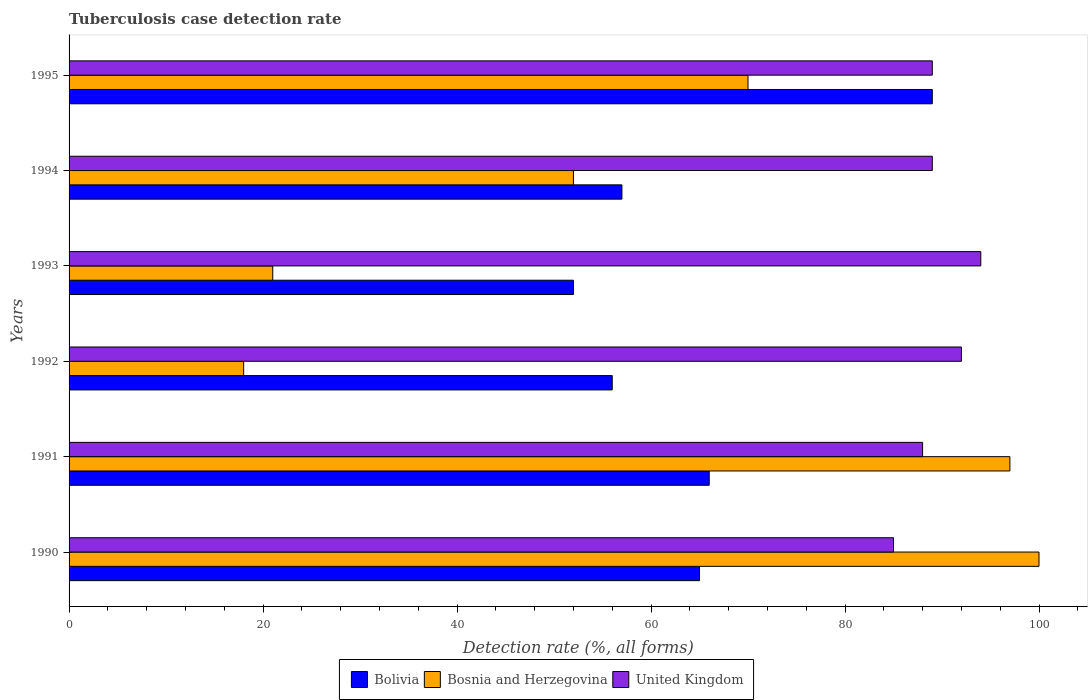What is the tuberculosis case detection rate in in Bolivia in 1993?
Your answer should be very brief. 52. Across all years, what is the maximum tuberculosis case detection rate in in Bolivia?
Provide a short and direct response. 89. Across all years, what is the minimum tuberculosis case detection rate in in Bolivia?
Offer a very short reply. 52. What is the total tuberculosis case detection rate in in Bosnia and Herzegovina in the graph?
Your response must be concise. 358. What is the difference between the tuberculosis case detection rate in in United Kingdom in 1992 and that in 1995?
Give a very brief answer. 3. What is the difference between the tuberculosis case detection rate in in Bosnia and Herzegovina in 1993 and the tuberculosis case detection rate in in United Kingdom in 1992?
Provide a short and direct response. -71. What is the average tuberculosis case detection rate in in Bolivia per year?
Make the answer very short. 64.17. In the year 1994, what is the difference between the tuberculosis case detection rate in in United Kingdom and tuberculosis case detection rate in in Bosnia and Herzegovina?
Your response must be concise. 37. In how many years, is the tuberculosis case detection rate in in United Kingdom greater than 92 %?
Your response must be concise. 1. What is the ratio of the tuberculosis case detection rate in in Bosnia and Herzegovina in 1992 to that in 1994?
Provide a succinct answer. 0.35. Is the tuberculosis case detection rate in in Bosnia and Herzegovina in 1990 less than that in 1991?
Your answer should be very brief. No. Is the difference between the tuberculosis case detection rate in in United Kingdom in 1992 and 1994 greater than the difference between the tuberculosis case detection rate in in Bosnia and Herzegovina in 1992 and 1994?
Provide a succinct answer. Yes. What is the difference between the highest and the second highest tuberculosis case detection rate in in United Kingdom?
Make the answer very short. 2. What is the difference between the highest and the lowest tuberculosis case detection rate in in Bolivia?
Ensure brevity in your answer.  37. In how many years, is the tuberculosis case detection rate in in Bolivia greater than the average tuberculosis case detection rate in in Bolivia taken over all years?
Give a very brief answer. 3. Is the sum of the tuberculosis case detection rate in in Bosnia and Herzegovina in 1991 and 1994 greater than the maximum tuberculosis case detection rate in in Bolivia across all years?
Give a very brief answer. Yes. What does the 3rd bar from the bottom in 1995 represents?
Your answer should be compact. United Kingdom. Are the values on the major ticks of X-axis written in scientific E-notation?
Your answer should be compact. No. Where does the legend appear in the graph?
Offer a very short reply. Bottom center. What is the title of the graph?
Offer a very short reply. Tuberculosis case detection rate. Does "Gabon" appear as one of the legend labels in the graph?
Provide a succinct answer. No. What is the label or title of the X-axis?
Give a very brief answer. Detection rate (%, all forms). What is the Detection rate (%, all forms) in United Kingdom in 1990?
Ensure brevity in your answer.  85. What is the Detection rate (%, all forms) in Bosnia and Herzegovina in 1991?
Offer a terse response. 97. What is the Detection rate (%, all forms) in Bolivia in 1992?
Your answer should be very brief. 56. What is the Detection rate (%, all forms) of Bosnia and Herzegovina in 1992?
Make the answer very short. 18. What is the Detection rate (%, all forms) of United Kingdom in 1992?
Make the answer very short. 92. What is the Detection rate (%, all forms) in Bosnia and Herzegovina in 1993?
Keep it short and to the point. 21. What is the Detection rate (%, all forms) in United Kingdom in 1993?
Your answer should be very brief. 94. What is the Detection rate (%, all forms) in United Kingdom in 1994?
Keep it short and to the point. 89. What is the Detection rate (%, all forms) in Bolivia in 1995?
Provide a succinct answer. 89. What is the Detection rate (%, all forms) in United Kingdom in 1995?
Give a very brief answer. 89. Across all years, what is the maximum Detection rate (%, all forms) of Bolivia?
Your answer should be compact. 89. Across all years, what is the maximum Detection rate (%, all forms) in Bosnia and Herzegovina?
Offer a terse response. 100. Across all years, what is the maximum Detection rate (%, all forms) in United Kingdom?
Provide a short and direct response. 94. Across all years, what is the minimum Detection rate (%, all forms) of Bolivia?
Give a very brief answer. 52. Across all years, what is the minimum Detection rate (%, all forms) of Bosnia and Herzegovina?
Give a very brief answer. 18. What is the total Detection rate (%, all forms) in Bolivia in the graph?
Provide a succinct answer. 385. What is the total Detection rate (%, all forms) of Bosnia and Herzegovina in the graph?
Make the answer very short. 358. What is the total Detection rate (%, all forms) in United Kingdom in the graph?
Provide a succinct answer. 537. What is the difference between the Detection rate (%, all forms) of United Kingdom in 1990 and that in 1991?
Your answer should be very brief. -3. What is the difference between the Detection rate (%, all forms) of Bolivia in 1990 and that in 1992?
Your answer should be compact. 9. What is the difference between the Detection rate (%, all forms) of Bolivia in 1990 and that in 1993?
Your answer should be compact. 13. What is the difference between the Detection rate (%, all forms) in Bosnia and Herzegovina in 1990 and that in 1993?
Provide a short and direct response. 79. What is the difference between the Detection rate (%, all forms) in United Kingdom in 1990 and that in 1993?
Give a very brief answer. -9. What is the difference between the Detection rate (%, all forms) of Bosnia and Herzegovina in 1990 and that in 1994?
Your answer should be very brief. 48. What is the difference between the Detection rate (%, all forms) of United Kingdom in 1990 and that in 1994?
Your response must be concise. -4. What is the difference between the Detection rate (%, all forms) of United Kingdom in 1990 and that in 1995?
Your answer should be very brief. -4. What is the difference between the Detection rate (%, all forms) in Bolivia in 1991 and that in 1992?
Give a very brief answer. 10. What is the difference between the Detection rate (%, all forms) of Bosnia and Herzegovina in 1991 and that in 1992?
Your response must be concise. 79. What is the difference between the Detection rate (%, all forms) in United Kingdom in 1991 and that in 1992?
Provide a short and direct response. -4. What is the difference between the Detection rate (%, all forms) in Bolivia in 1991 and that in 1993?
Ensure brevity in your answer.  14. What is the difference between the Detection rate (%, all forms) of Bosnia and Herzegovina in 1991 and that in 1993?
Make the answer very short. 76. What is the difference between the Detection rate (%, all forms) in United Kingdom in 1991 and that in 1993?
Give a very brief answer. -6. What is the difference between the Detection rate (%, all forms) of Bolivia in 1991 and that in 1994?
Your answer should be compact. 9. What is the difference between the Detection rate (%, all forms) of Bolivia in 1991 and that in 1995?
Make the answer very short. -23. What is the difference between the Detection rate (%, all forms) of Bosnia and Herzegovina in 1991 and that in 1995?
Offer a terse response. 27. What is the difference between the Detection rate (%, all forms) in Bolivia in 1992 and that in 1993?
Provide a short and direct response. 4. What is the difference between the Detection rate (%, all forms) in Bosnia and Herzegovina in 1992 and that in 1993?
Provide a short and direct response. -3. What is the difference between the Detection rate (%, all forms) of Bosnia and Herzegovina in 1992 and that in 1994?
Offer a very short reply. -34. What is the difference between the Detection rate (%, all forms) in Bolivia in 1992 and that in 1995?
Ensure brevity in your answer.  -33. What is the difference between the Detection rate (%, all forms) of Bosnia and Herzegovina in 1992 and that in 1995?
Offer a very short reply. -52. What is the difference between the Detection rate (%, all forms) of Bosnia and Herzegovina in 1993 and that in 1994?
Keep it short and to the point. -31. What is the difference between the Detection rate (%, all forms) of United Kingdom in 1993 and that in 1994?
Offer a very short reply. 5. What is the difference between the Detection rate (%, all forms) of Bolivia in 1993 and that in 1995?
Your answer should be very brief. -37. What is the difference between the Detection rate (%, all forms) in Bosnia and Herzegovina in 1993 and that in 1995?
Your answer should be compact. -49. What is the difference between the Detection rate (%, all forms) in Bolivia in 1994 and that in 1995?
Your answer should be very brief. -32. What is the difference between the Detection rate (%, all forms) in United Kingdom in 1994 and that in 1995?
Your answer should be very brief. 0. What is the difference between the Detection rate (%, all forms) of Bolivia in 1990 and the Detection rate (%, all forms) of Bosnia and Herzegovina in 1991?
Offer a terse response. -32. What is the difference between the Detection rate (%, all forms) of Bolivia in 1990 and the Detection rate (%, all forms) of United Kingdom in 1992?
Provide a short and direct response. -27. What is the difference between the Detection rate (%, all forms) of Bolivia in 1990 and the Detection rate (%, all forms) of Bosnia and Herzegovina in 1993?
Offer a terse response. 44. What is the difference between the Detection rate (%, all forms) of Bolivia in 1990 and the Detection rate (%, all forms) of United Kingdom in 1994?
Your answer should be compact. -24. What is the difference between the Detection rate (%, all forms) of Bosnia and Herzegovina in 1990 and the Detection rate (%, all forms) of United Kingdom in 1994?
Provide a short and direct response. 11. What is the difference between the Detection rate (%, all forms) in Bosnia and Herzegovina in 1991 and the Detection rate (%, all forms) in United Kingdom in 1993?
Ensure brevity in your answer.  3. What is the difference between the Detection rate (%, all forms) in Bolivia in 1991 and the Detection rate (%, all forms) in Bosnia and Herzegovina in 1994?
Provide a succinct answer. 14. What is the difference between the Detection rate (%, all forms) in Bolivia in 1991 and the Detection rate (%, all forms) in United Kingdom in 1994?
Your answer should be very brief. -23. What is the difference between the Detection rate (%, all forms) in Bolivia in 1991 and the Detection rate (%, all forms) in Bosnia and Herzegovina in 1995?
Your response must be concise. -4. What is the difference between the Detection rate (%, all forms) of Bolivia in 1992 and the Detection rate (%, all forms) of United Kingdom in 1993?
Offer a very short reply. -38. What is the difference between the Detection rate (%, all forms) of Bosnia and Herzegovina in 1992 and the Detection rate (%, all forms) of United Kingdom in 1993?
Offer a very short reply. -76. What is the difference between the Detection rate (%, all forms) in Bolivia in 1992 and the Detection rate (%, all forms) in Bosnia and Herzegovina in 1994?
Offer a very short reply. 4. What is the difference between the Detection rate (%, all forms) of Bolivia in 1992 and the Detection rate (%, all forms) of United Kingdom in 1994?
Make the answer very short. -33. What is the difference between the Detection rate (%, all forms) in Bosnia and Herzegovina in 1992 and the Detection rate (%, all forms) in United Kingdom in 1994?
Make the answer very short. -71. What is the difference between the Detection rate (%, all forms) in Bolivia in 1992 and the Detection rate (%, all forms) in Bosnia and Herzegovina in 1995?
Ensure brevity in your answer.  -14. What is the difference between the Detection rate (%, all forms) in Bolivia in 1992 and the Detection rate (%, all forms) in United Kingdom in 1995?
Keep it short and to the point. -33. What is the difference between the Detection rate (%, all forms) of Bosnia and Herzegovina in 1992 and the Detection rate (%, all forms) of United Kingdom in 1995?
Ensure brevity in your answer.  -71. What is the difference between the Detection rate (%, all forms) of Bolivia in 1993 and the Detection rate (%, all forms) of United Kingdom in 1994?
Provide a succinct answer. -37. What is the difference between the Detection rate (%, all forms) in Bosnia and Herzegovina in 1993 and the Detection rate (%, all forms) in United Kingdom in 1994?
Give a very brief answer. -68. What is the difference between the Detection rate (%, all forms) of Bolivia in 1993 and the Detection rate (%, all forms) of Bosnia and Herzegovina in 1995?
Your response must be concise. -18. What is the difference between the Detection rate (%, all forms) of Bolivia in 1993 and the Detection rate (%, all forms) of United Kingdom in 1995?
Give a very brief answer. -37. What is the difference between the Detection rate (%, all forms) of Bosnia and Herzegovina in 1993 and the Detection rate (%, all forms) of United Kingdom in 1995?
Keep it short and to the point. -68. What is the difference between the Detection rate (%, all forms) in Bolivia in 1994 and the Detection rate (%, all forms) in Bosnia and Herzegovina in 1995?
Your answer should be compact. -13. What is the difference between the Detection rate (%, all forms) of Bolivia in 1994 and the Detection rate (%, all forms) of United Kingdom in 1995?
Provide a short and direct response. -32. What is the difference between the Detection rate (%, all forms) in Bosnia and Herzegovina in 1994 and the Detection rate (%, all forms) in United Kingdom in 1995?
Provide a short and direct response. -37. What is the average Detection rate (%, all forms) of Bolivia per year?
Provide a short and direct response. 64.17. What is the average Detection rate (%, all forms) of Bosnia and Herzegovina per year?
Make the answer very short. 59.67. What is the average Detection rate (%, all forms) in United Kingdom per year?
Ensure brevity in your answer.  89.5. In the year 1990, what is the difference between the Detection rate (%, all forms) of Bolivia and Detection rate (%, all forms) of Bosnia and Herzegovina?
Keep it short and to the point. -35. In the year 1991, what is the difference between the Detection rate (%, all forms) in Bolivia and Detection rate (%, all forms) in Bosnia and Herzegovina?
Ensure brevity in your answer.  -31. In the year 1992, what is the difference between the Detection rate (%, all forms) in Bolivia and Detection rate (%, all forms) in Bosnia and Herzegovina?
Your answer should be compact. 38. In the year 1992, what is the difference between the Detection rate (%, all forms) in Bolivia and Detection rate (%, all forms) in United Kingdom?
Your answer should be very brief. -36. In the year 1992, what is the difference between the Detection rate (%, all forms) of Bosnia and Herzegovina and Detection rate (%, all forms) of United Kingdom?
Provide a short and direct response. -74. In the year 1993, what is the difference between the Detection rate (%, all forms) of Bolivia and Detection rate (%, all forms) of United Kingdom?
Ensure brevity in your answer.  -42. In the year 1993, what is the difference between the Detection rate (%, all forms) of Bosnia and Herzegovina and Detection rate (%, all forms) of United Kingdom?
Your response must be concise. -73. In the year 1994, what is the difference between the Detection rate (%, all forms) in Bolivia and Detection rate (%, all forms) in Bosnia and Herzegovina?
Your answer should be very brief. 5. In the year 1994, what is the difference between the Detection rate (%, all forms) of Bolivia and Detection rate (%, all forms) of United Kingdom?
Your answer should be very brief. -32. In the year 1994, what is the difference between the Detection rate (%, all forms) of Bosnia and Herzegovina and Detection rate (%, all forms) of United Kingdom?
Your response must be concise. -37. What is the ratio of the Detection rate (%, all forms) in Bosnia and Herzegovina in 1990 to that in 1991?
Your answer should be very brief. 1.03. What is the ratio of the Detection rate (%, all forms) of United Kingdom in 1990 to that in 1991?
Keep it short and to the point. 0.97. What is the ratio of the Detection rate (%, all forms) in Bolivia in 1990 to that in 1992?
Give a very brief answer. 1.16. What is the ratio of the Detection rate (%, all forms) of Bosnia and Herzegovina in 1990 to that in 1992?
Ensure brevity in your answer.  5.56. What is the ratio of the Detection rate (%, all forms) in United Kingdom in 1990 to that in 1992?
Keep it short and to the point. 0.92. What is the ratio of the Detection rate (%, all forms) in Bosnia and Herzegovina in 1990 to that in 1993?
Provide a short and direct response. 4.76. What is the ratio of the Detection rate (%, all forms) of United Kingdom in 1990 to that in 1993?
Offer a terse response. 0.9. What is the ratio of the Detection rate (%, all forms) in Bolivia in 1990 to that in 1994?
Offer a terse response. 1.14. What is the ratio of the Detection rate (%, all forms) in Bosnia and Herzegovina in 1990 to that in 1994?
Give a very brief answer. 1.92. What is the ratio of the Detection rate (%, all forms) in United Kingdom in 1990 to that in 1994?
Provide a short and direct response. 0.96. What is the ratio of the Detection rate (%, all forms) of Bolivia in 1990 to that in 1995?
Your answer should be very brief. 0.73. What is the ratio of the Detection rate (%, all forms) in Bosnia and Herzegovina in 1990 to that in 1995?
Offer a very short reply. 1.43. What is the ratio of the Detection rate (%, all forms) of United Kingdom in 1990 to that in 1995?
Provide a succinct answer. 0.96. What is the ratio of the Detection rate (%, all forms) in Bolivia in 1991 to that in 1992?
Your answer should be compact. 1.18. What is the ratio of the Detection rate (%, all forms) in Bosnia and Herzegovina in 1991 to that in 1992?
Offer a very short reply. 5.39. What is the ratio of the Detection rate (%, all forms) in United Kingdom in 1991 to that in 1992?
Your answer should be compact. 0.96. What is the ratio of the Detection rate (%, all forms) in Bolivia in 1991 to that in 1993?
Keep it short and to the point. 1.27. What is the ratio of the Detection rate (%, all forms) of Bosnia and Herzegovina in 1991 to that in 1993?
Offer a terse response. 4.62. What is the ratio of the Detection rate (%, all forms) of United Kingdom in 1991 to that in 1993?
Give a very brief answer. 0.94. What is the ratio of the Detection rate (%, all forms) in Bolivia in 1991 to that in 1994?
Offer a terse response. 1.16. What is the ratio of the Detection rate (%, all forms) in Bosnia and Herzegovina in 1991 to that in 1994?
Your answer should be very brief. 1.87. What is the ratio of the Detection rate (%, all forms) in United Kingdom in 1991 to that in 1994?
Your answer should be compact. 0.99. What is the ratio of the Detection rate (%, all forms) of Bolivia in 1991 to that in 1995?
Your answer should be very brief. 0.74. What is the ratio of the Detection rate (%, all forms) in Bosnia and Herzegovina in 1991 to that in 1995?
Give a very brief answer. 1.39. What is the ratio of the Detection rate (%, all forms) in United Kingdom in 1992 to that in 1993?
Give a very brief answer. 0.98. What is the ratio of the Detection rate (%, all forms) in Bolivia in 1992 to that in 1994?
Give a very brief answer. 0.98. What is the ratio of the Detection rate (%, all forms) in Bosnia and Herzegovina in 1992 to that in 1994?
Offer a very short reply. 0.35. What is the ratio of the Detection rate (%, all forms) of United Kingdom in 1992 to that in 1994?
Offer a terse response. 1.03. What is the ratio of the Detection rate (%, all forms) of Bolivia in 1992 to that in 1995?
Offer a very short reply. 0.63. What is the ratio of the Detection rate (%, all forms) of Bosnia and Herzegovina in 1992 to that in 1995?
Provide a short and direct response. 0.26. What is the ratio of the Detection rate (%, all forms) in United Kingdom in 1992 to that in 1995?
Offer a very short reply. 1.03. What is the ratio of the Detection rate (%, all forms) in Bolivia in 1993 to that in 1994?
Keep it short and to the point. 0.91. What is the ratio of the Detection rate (%, all forms) in Bosnia and Herzegovina in 1993 to that in 1994?
Offer a terse response. 0.4. What is the ratio of the Detection rate (%, all forms) of United Kingdom in 1993 to that in 1994?
Keep it short and to the point. 1.06. What is the ratio of the Detection rate (%, all forms) in Bolivia in 1993 to that in 1995?
Provide a short and direct response. 0.58. What is the ratio of the Detection rate (%, all forms) of Bosnia and Herzegovina in 1993 to that in 1995?
Your answer should be compact. 0.3. What is the ratio of the Detection rate (%, all forms) in United Kingdom in 1993 to that in 1995?
Your answer should be very brief. 1.06. What is the ratio of the Detection rate (%, all forms) in Bolivia in 1994 to that in 1995?
Make the answer very short. 0.64. What is the ratio of the Detection rate (%, all forms) in Bosnia and Herzegovina in 1994 to that in 1995?
Keep it short and to the point. 0.74. What is the difference between the highest and the second highest Detection rate (%, all forms) in Bolivia?
Offer a very short reply. 23. What is the difference between the highest and the lowest Detection rate (%, all forms) of Bolivia?
Offer a very short reply. 37. What is the difference between the highest and the lowest Detection rate (%, all forms) in Bosnia and Herzegovina?
Provide a short and direct response. 82. 